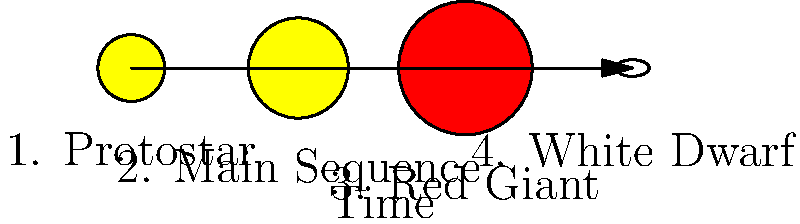In the context of equal access to healthcare education, consider the lifecycle of a star shown in the diagram. Which stage represents the longest period in a star's life, and how might this relate to the importance of long-term healthcare planning? To answer this question, let's examine each stage of a star's lifecycle and its duration:

1. Protostar: This stage lasts for about 100,000 years, which is relatively short in astronomical terms.

2. Main Sequence: This is the longest stage in a star's life. For a star like our Sun, it lasts about 10 billion years. This is where the star spends most of its life, fusing hydrogen into helium in its core.

3. Red Giant: This stage lasts for about 1 billion years for a star like our Sun, which is significant but much shorter than the main sequence.

4. White Dwarf: While this stage can last for trillions of years, it represents the "death" of the star and is not considered part of its active life.

The Main Sequence (stage 2) represents the longest period in a star's life. This can be related to healthcare planning in the following ways:

- Just as the main sequence is the most stable and longest-lasting phase of a star's life, long-term healthcare planning aims to maintain a stable and healthy life for individuals over many years.

- The importance of preventive care and health education can be likened to the stable energy production of a main sequence star, helping to maintain health over a long period.

- Like how the main sequence determines much of a star's overall lifecycle, early and consistent healthcare interventions can significantly impact a person's long-term health outcomes.

- The long duration of the main sequence emphasizes the need for sustainable and accessible healthcare systems that can provide consistent care over many years, much like how a star sustains its energy output over billions of years.
Answer: Main Sequence stage 